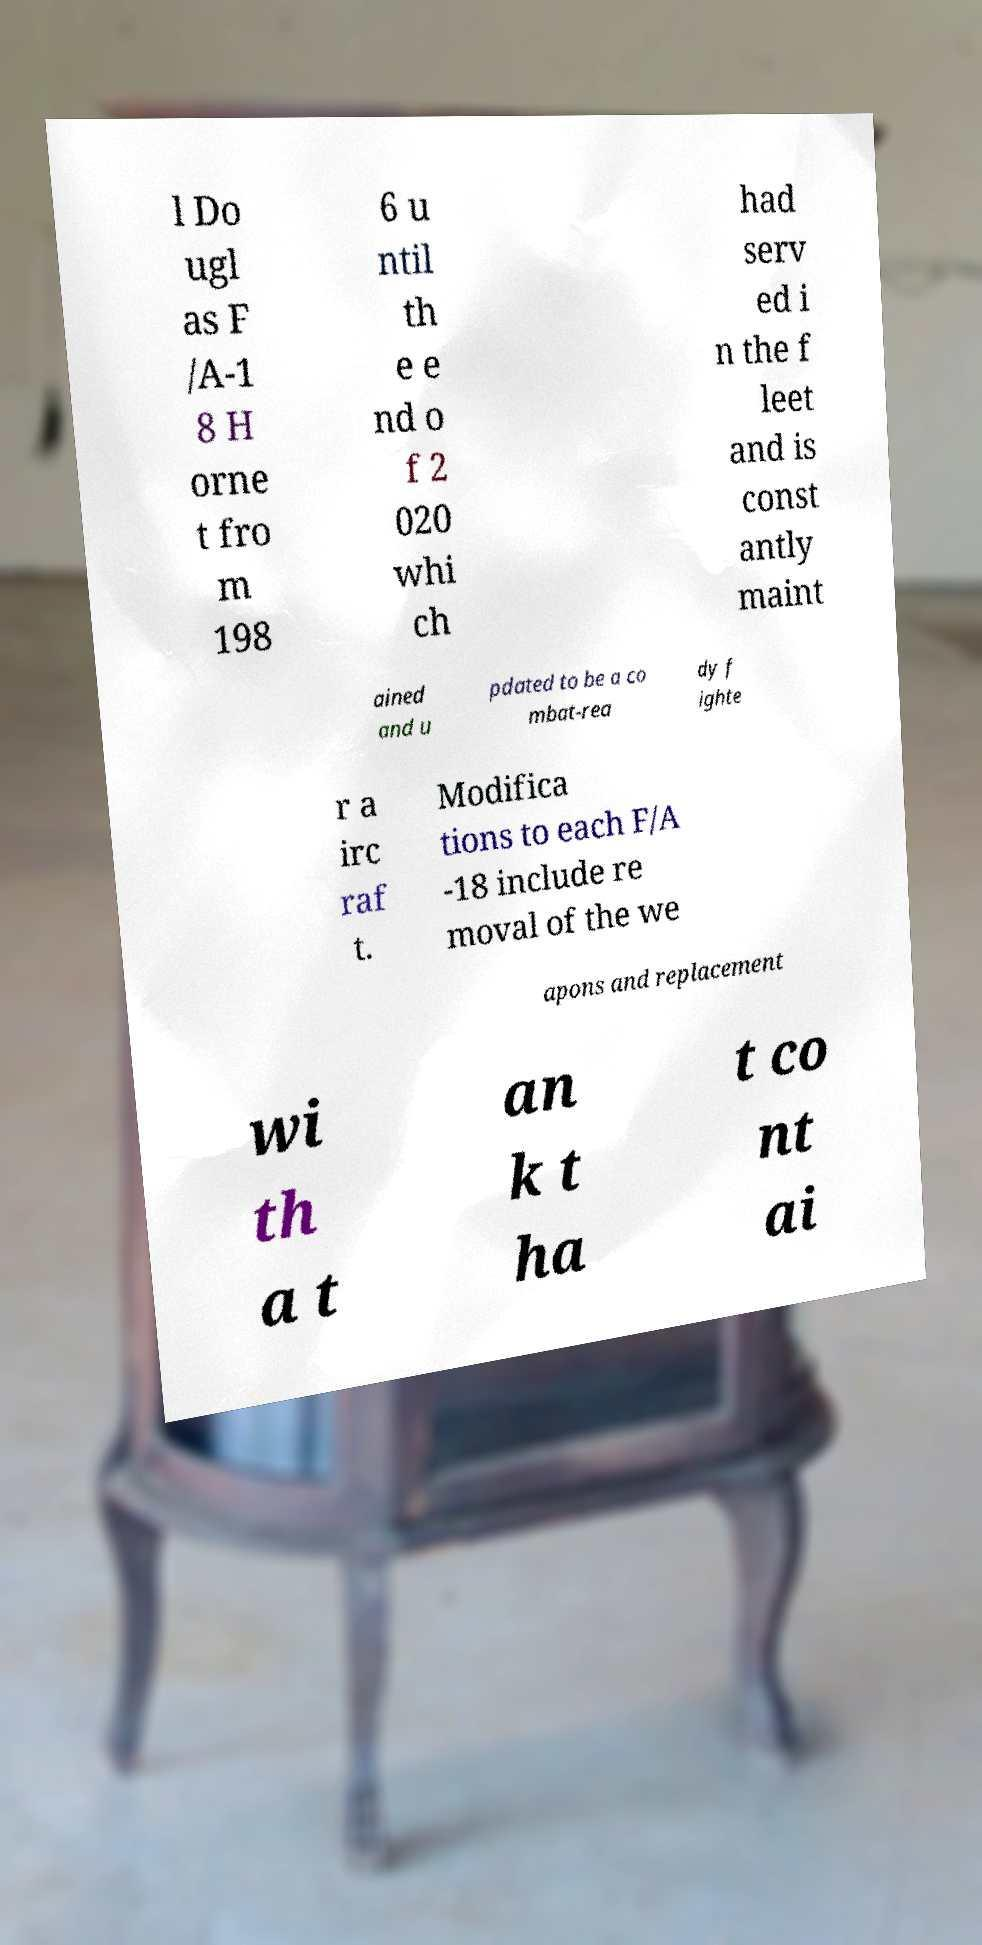There's text embedded in this image that I need extracted. Can you transcribe it verbatim? l Do ugl as F /A-1 8 H orne t fro m 198 6 u ntil th e e nd o f 2 020 whi ch had serv ed i n the f leet and is const antly maint ained and u pdated to be a co mbat-rea dy f ighte r a irc raf t. Modifica tions to each F/A -18 include re moval of the we apons and replacement wi th a t an k t ha t co nt ai 